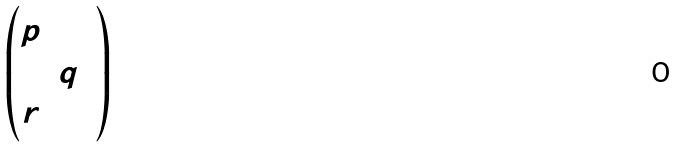<formula> <loc_0><loc_0><loc_500><loc_500>\begin{pmatrix} p & & \\ & q & \\ r & & \end{pmatrix}</formula> 